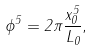Convert formula to latex. <formula><loc_0><loc_0><loc_500><loc_500>\phi ^ { 5 } = 2 \pi \frac { x ^ { 5 } _ { 0 } } { L _ { 0 } } ,</formula> 